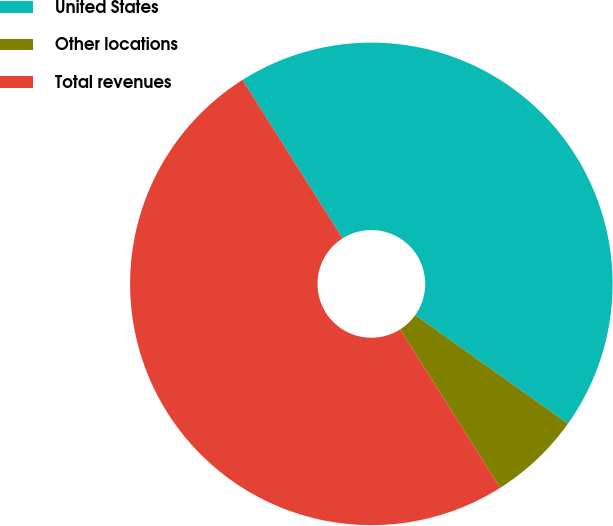<chart> <loc_0><loc_0><loc_500><loc_500><pie_chart><fcel>United States<fcel>Other locations<fcel>Total revenues<nl><fcel>43.8%<fcel>6.2%<fcel>50.0%<nl></chart> 